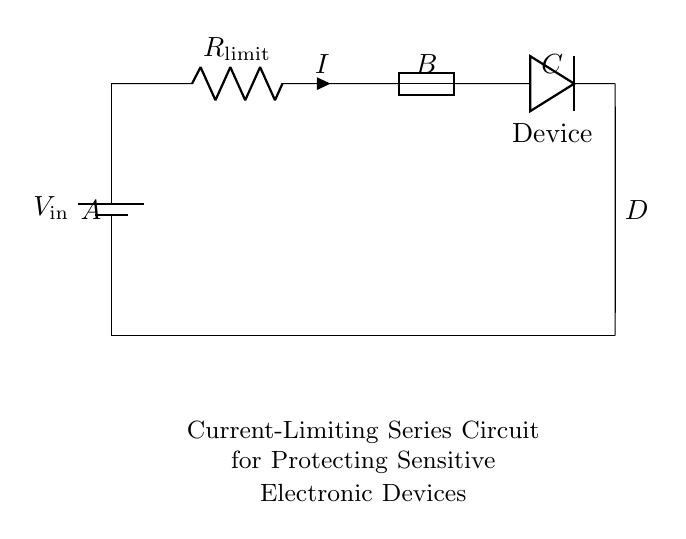What is the main purpose of this circuit? The main purpose is to protect sensitive electronic devices from excessive current by limiting the amount that can flow to them.
Answer: current limiting What component is used to limit the current? The current-limiting resistor is specifically designed to restrict the current flow through the circuit to safe levels for the connected device.
Answer: resistor What is the role of the fuse in this circuit? The fuse serves as an additional layer of protection by breaking the circuit if the current exceeds a certain threshold, preventing damage to the device.
Answer: protection Which component represents the sensitive electronic device? The diode represents the sensitive electronic device in this circuit, connected in the direction that allows current flow when the device is operating properly.
Answer: device What is the voltage source in this circuit? The voltage source is identified as V in, which provides the necessary potential to drive current through the circuit components.
Answer: V in What is the relationship between the resistor and current in this circuit? According to Ohm's law, the current through the resistor will be directly proportional to the voltage across it and inversely proportional to its resistance, meaning higher resistance results in lower current.
Answer: inverse relationship How are the components connected in this circuit? The components are connected in a series configuration, meaning the current flows through each component one after the other without branching.
Answer: series configuration 